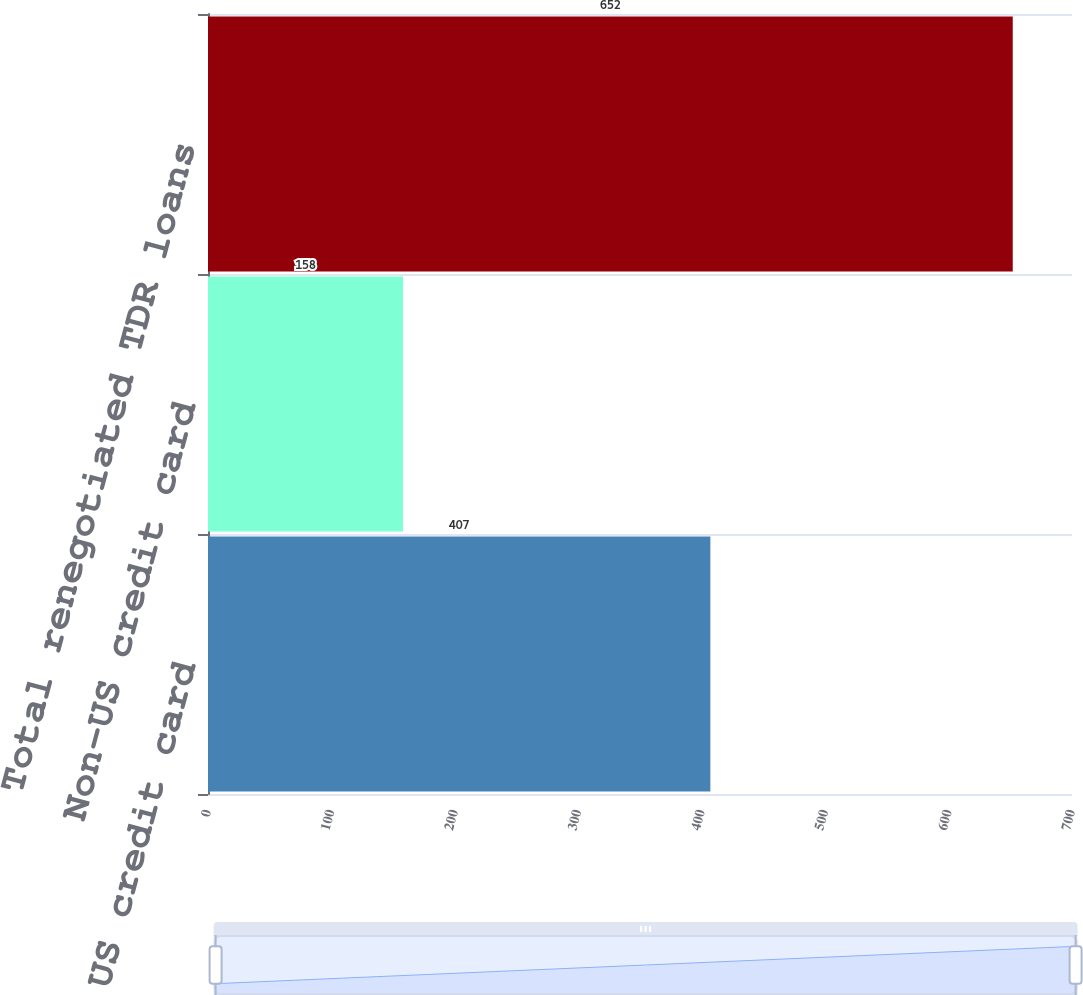<chart> <loc_0><loc_0><loc_500><loc_500><bar_chart><fcel>US credit card<fcel>Non-US credit card<fcel>Total renegotiated TDR loans<nl><fcel>407<fcel>158<fcel>652<nl></chart> 